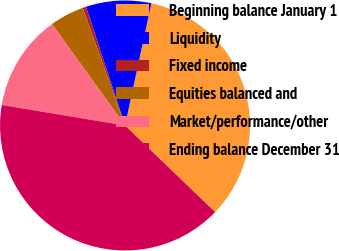<chart> <loc_0><loc_0><loc_500><loc_500><pie_chart><fcel>Beginning balance January 1<fcel>Liquidity<fcel>Fixed income<fcel>Equities balanced and<fcel>Market/performance/other<fcel>Ending balance December 31<nl><fcel>33.81%<fcel>8.44%<fcel>0.44%<fcel>4.44%<fcel>12.44%<fcel>40.44%<nl></chart> 